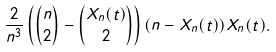<formula> <loc_0><loc_0><loc_500><loc_500>\frac { 2 } { n ^ { 3 } } \left ( { n \choose 2 } - { X _ { n } ( t ) \choose 2 } \right ) ( n - X _ { n } ( t ) ) X _ { n } ( t ) .</formula> 